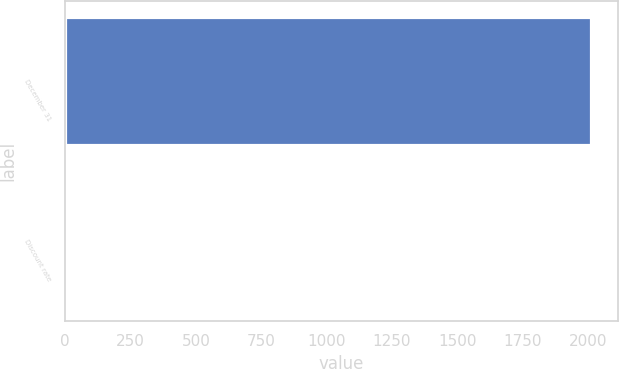<chart> <loc_0><loc_0><loc_500><loc_500><bar_chart><fcel>December 31<fcel>Discount rate<nl><fcel>2013<fcel>4.25<nl></chart> 